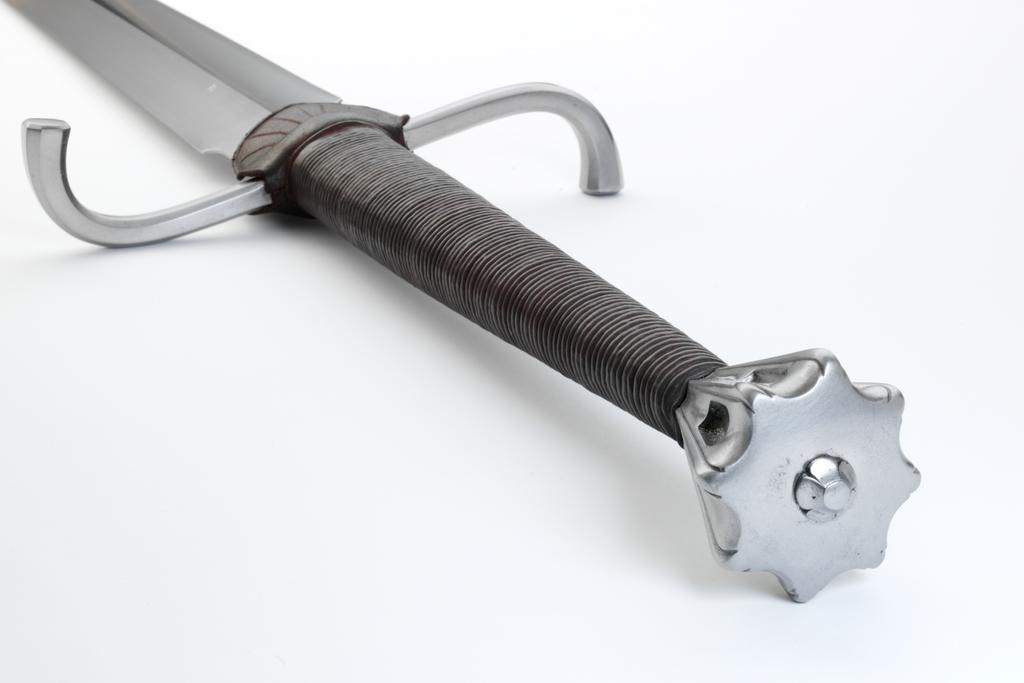Please provide a concise description of this image. In this image we can see a sword. 